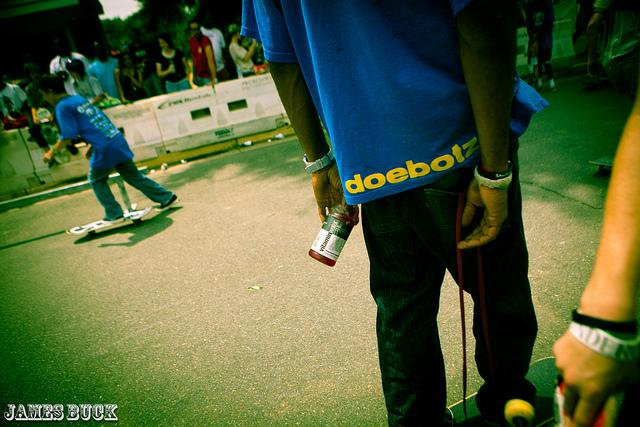What flavoured beverage is in the bottle? Please explain your reasoning. water. The beverage is bottled vitamin water. 